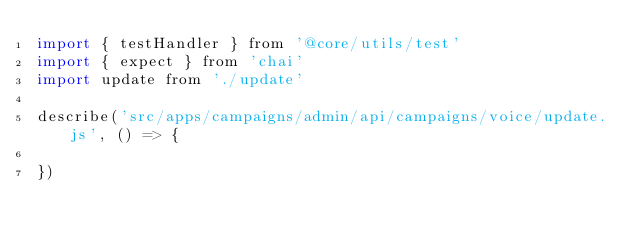Convert code to text. <code><loc_0><loc_0><loc_500><loc_500><_JavaScript_>import { testHandler } from '@core/utils/test'
import { expect } from 'chai'
import update from './update'

describe('src/apps/campaigns/admin/api/campaigns/voice/update.js', () => {

})
</code> 